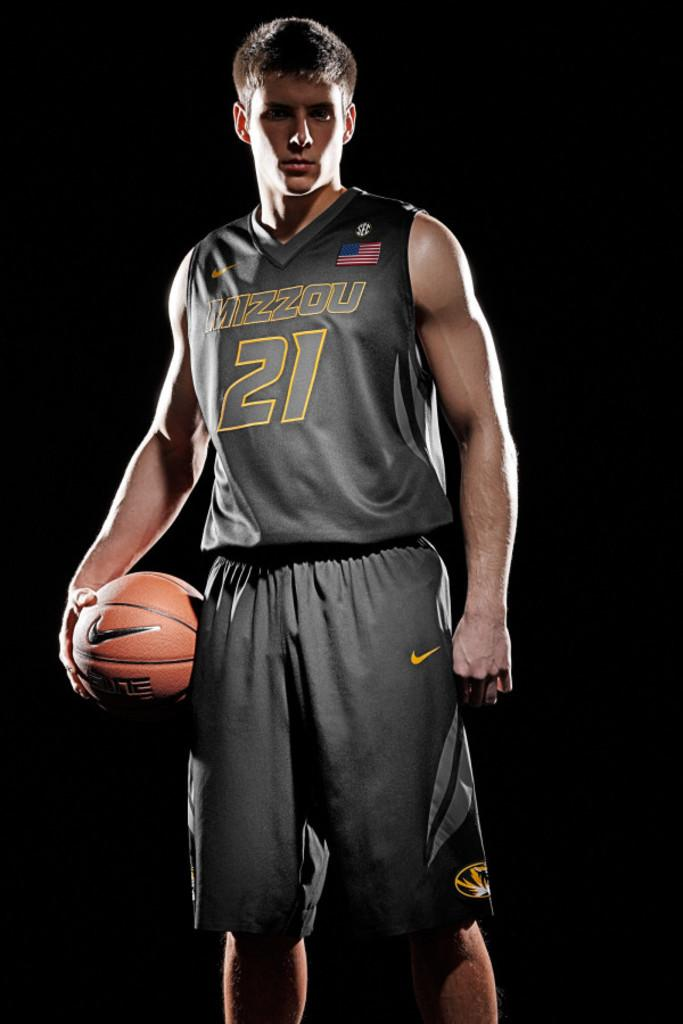<image>
Render a clear and concise summary of the photo. A basketball player is posing in a dark background with a jersey that says Mizzou 21. 